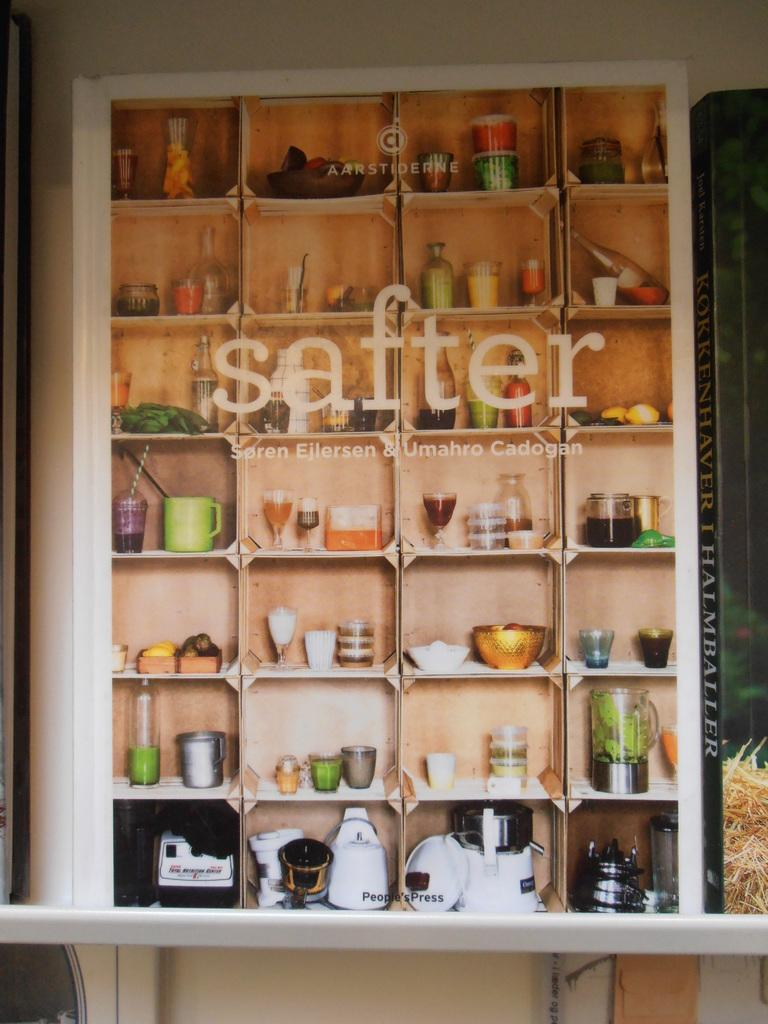<image>
Create a compact narrative representing the image presented. the word safter that is on the wall 